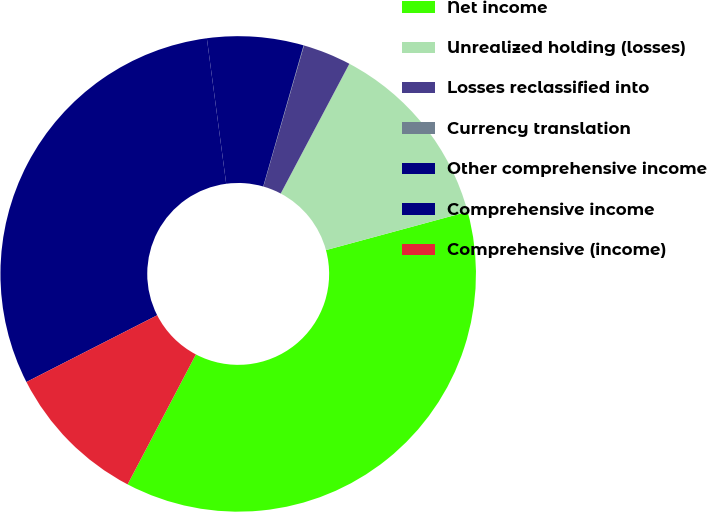Convert chart. <chart><loc_0><loc_0><loc_500><loc_500><pie_chart><fcel>Net income<fcel>Unrealized holding (losses)<fcel>Losses reclassified into<fcel>Currency translation<fcel>Other comprehensive income<fcel>Comprehensive income<fcel>Comprehensive (income)<nl><fcel>36.92%<fcel>13.04%<fcel>3.28%<fcel>0.03%<fcel>6.54%<fcel>30.41%<fcel>9.79%<nl></chart> 